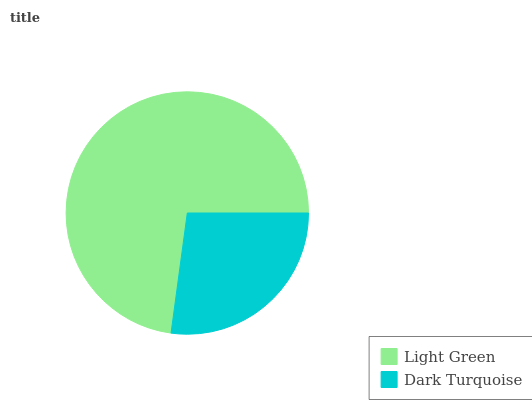Is Dark Turquoise the minimum?
Answer yes or no. Yes. Is Light Green the maximum?
Answer yes or no. Yes. Is Dark Turquoise the maximum?
Answer yes or no. No. Is Light Green greater than Dark Turquoise?
Answer yes or no. Yes. Is Dark Turquoise less than Light Green?
Answer yes or no. Yes. Is Dark Turquoise greater than Light Green?
Answer yes or no. No. Is Light Green less than Dark Turquoise?
Answer yes or no. No. Is Light Green the high median?
Answer yes or no. Yes. Is Dark Turquoise the low median?
Answer yes or no. Yes. Is Dark Turquoise the high median?
Answer yes or no. No. Is Light Green the low median?
Answer yes or no. No. 